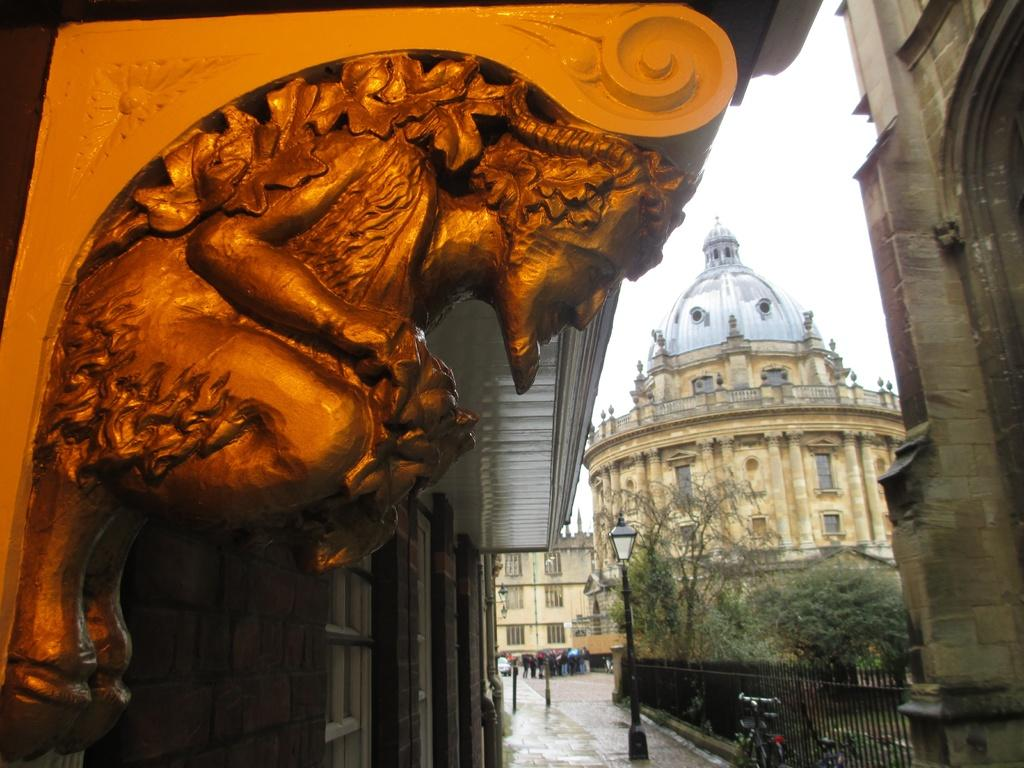What type of structures can be seen in the image? There are buildings in the image. What natural elements are present in the image? There are trees in the image. What artistic feature can be found in the image? There is a sculpture in the image. What is happening on the road in the image? There are people on the road in the image. How many apples are hanging from the trees in the image? There are no apples present in the image, as the trees are not specifically identified as fruit-bearing trees. What angle is the sculpture positioned at in the image? The angle of the sculpture cannot be determined from the image alone, as it depends on the perspective of the viewer. 